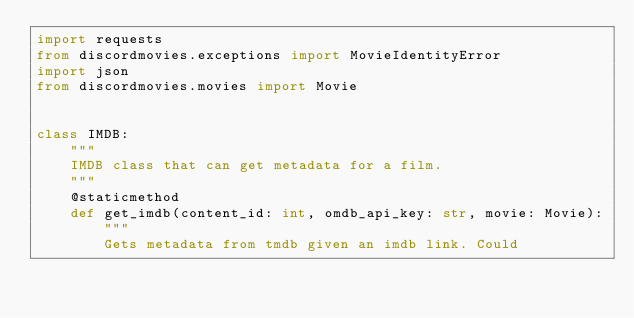Convert code to text. <code><loc_0><loc_0><loc_500><loc_500><_Python_>import requests
from discordmovies.exceptions import MovieIdentityError
import json
from discordmovies.movies import Movie


class IMDB:
    """
    IMDB class that can get metadata for a film.
    """
    @staticmethod
    def get_imdb(content_id: int, omdb_api_key: str, movie: Movie):
        """
        Gets metadata from tmdb given an imdb link. Could</code> 